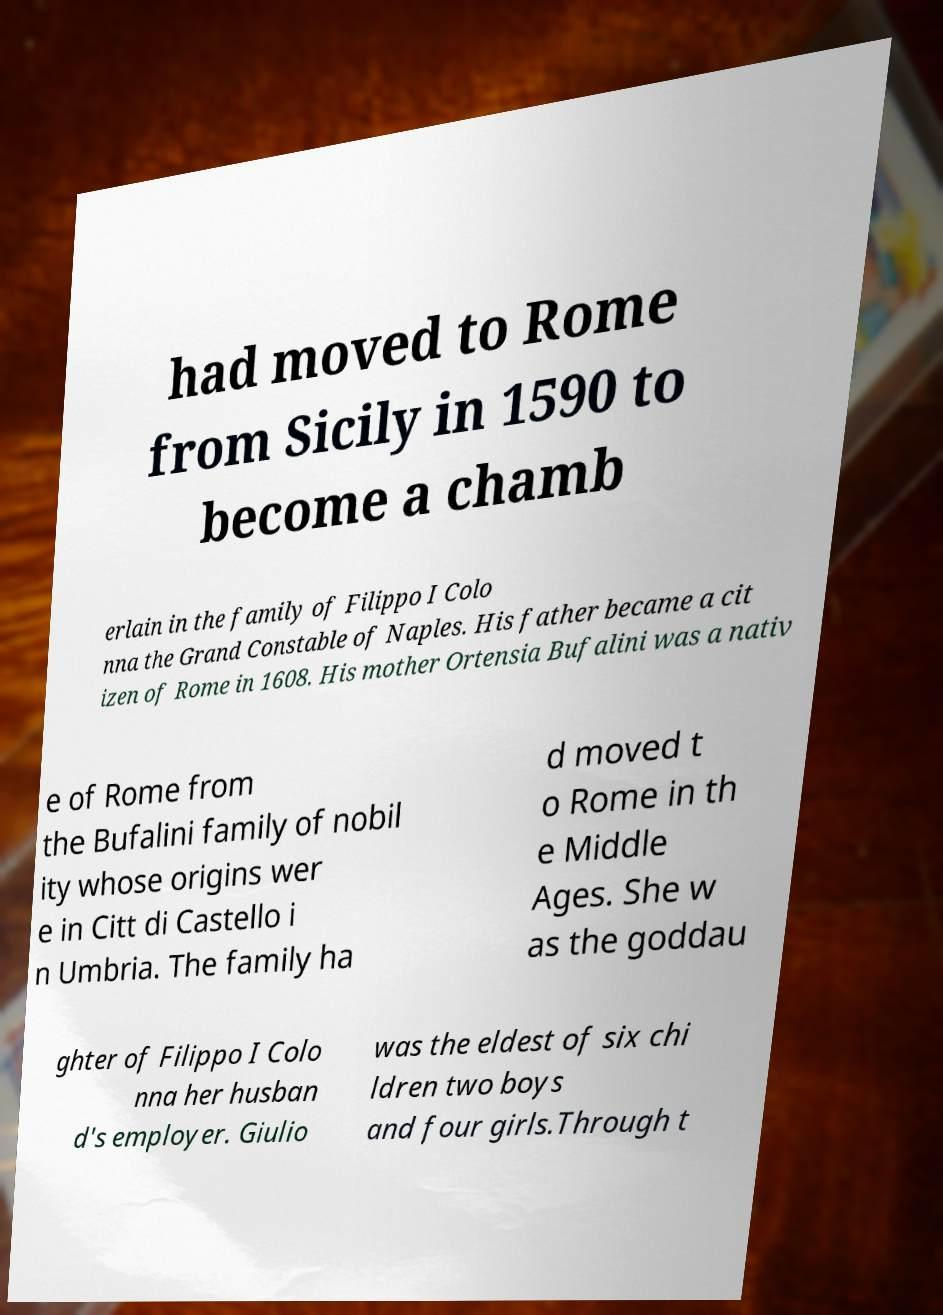I need the written content from this picture converted into text. Can you do that? had moved to Rome from Sicily in 1590 to become a chamb erlain in the family of Filippo I Colo nna the Grand Constable of Naples. His father became a cit izen of Rome in 1608. His mother Ortensia Bufalini was a nativ e of Rome from the Bufalini family of nobil ity whose origins wer e in Citt di Castello i n Umbria. The family ha d moved t o Rome in th e Middle Ages. She w as the goddau ghter of Filippo I Colo nna her husban d's employer. Giulio was the eldest of six chi ldren two boys and four girls.Through t 